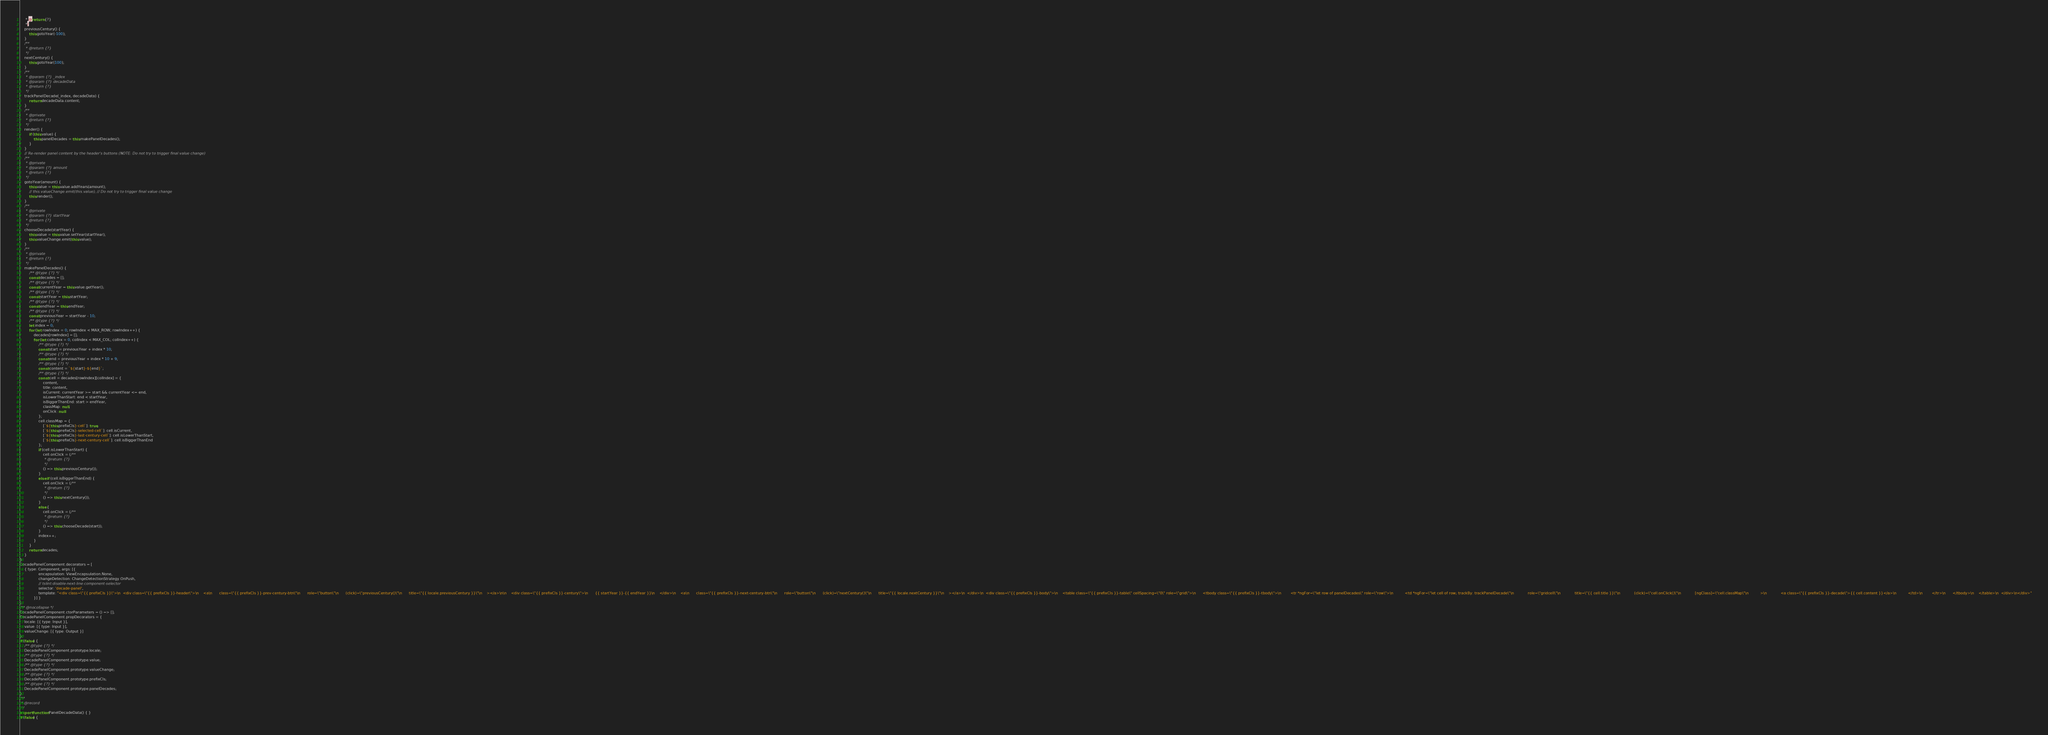<code> <loc_0><loc_0><loc_500><loc_500><_JavaScript_>     * @return {?}
     */
    previousCentury() {
        this.gotoYear(-100);
    }
    /**
     * @return {?}
     */
    nextCentury() {
        this.gotoYear(100);
    }
    /**
     * @param {?} _index
     * @param {?} decadeData
     * @return {?}
     */
    trackPanelDecade(_index, decadeData) {
        return decadeData.content;
    }
    /**
     * @private
     * @return {?}
     */
    render() {
        if (this.value) {
            this.panelDecades = this.makePanelDecades();
        }
    }
    // Re-render panel content by the header's buttons (NOTE: Do not try to trigger final value change)
    /**
     * @private
     * @param {?} amount
     * @return {?}
     */
    gotoYear(amount) {
        this.value = this.value.addYears(amount);
        // this.valueChange.emit(this.value); // Do not try to trigger final value change
        this.render();
    }
    /**
     * @private
     * @param {?} startYear
     * @return {?}
     */
    chooseDecade(startYear) {
        this.value = this.value.setYear(startYear);
        this.valueChange.emit(this.value);
    }
    /**
     * @private
     * @return {?}
     */
    makePanelDecades() {
        /** @type {?} */
        const decades = [];
        /** @type {?} */
        const currentYear = this.value.getYear();
        /** @type {?} */
        const startYear = this.startYear;
        /** @type {?} */
        const endYear = this.endYear;
        /** @type {?} */
        const previousYear = startYear - 10;
        /** @type {?} */
        let index = 0;
        for (let rowIndex = 0; rowIndex < MAX_ROW; rowIndex++) {
            decades[rowIndex] = [];
            for (let colIndex = 0; colIndex < MAX_COL; colIndex++) {
                /** @type {?} */
                const start = previousYear + index * 10;
                /** @type {?} */
                const end = previousYear + index * 10 + 9;
                /** @type {?} */
                const content = `${start}-${end}`;
                /** @type {?} */
                const cell = decades[rowIndex][colIndex] = {
                    content,
                    title: content,
                    isCurrent: currentYear >= start && currentYear <= end,
                    isLowerThanStart: end < startYear,
                    isBiggerThanEnd: start > endYear,
                    classMap: null,
                    onClick: null
                };
                cell.classMap = {
                    [`${this.prefixCls}-cell`]: true,
                    [`${this.prefixCls}-selected-cell`]: cell.isCurrent,
                    [`${this.prefixCls}-last-century-cell`]: cell.isLowerThanStart,
                    [`${this.prefixCls}-next-century-cell`]: cell.isBiggerThanEnd
                };
                if (cell.isLowerThanStart) {
                    cell.onClick = (/**
                     * @return {?}
                     */
                    () => this.previousCentury());
                }
                else if (cell.isBiggerThanEnd) {
                    cell.onClick = (/**
                     * @return {?}
                     */
                    () => this.nextCentury());
                }
                else {
                    cell.onClick = (/**
                     * @return {?}
                     */
                    () => this.chooseDecade(start));
                }
                index++;
            }
        }
        return decades;
    }
}
DecadePanelComponent.decorators = [
    { type: Component, args: [{
                encapsulation: ViewEncapsulation.None,
                changeDetection: ChangeDetectionStrategy.OnPush,
                // tslint:disable-next-line:component-selector
                selector: 'decade-panel',
                template: "<div class=\"{{ prefixCls }}\">\n  <div class=\"{{ prefixCls }}-header\">\n    <a\n      class=\"{{ prefixCls }}-prev-century-btn\"\n      role=\"button\"\n      (click)=\"previousCentury()\"\n      title=\"{{ locale.previousCentury }}\"\n    ></a>\n\n    <div class=\"{{ prefixCls }}-century\">\n      {{ startYear }}-{{ endYear }}\n    </div>\n    <a\n      class=\"{{ prefixCls }}-next-century-btn\"\n      role=\"button\"\n      (click)=\"nextCentury()\"\n      title=\"{{ locale.nextCentury }}\"\n    ></a>\n  </div>\n  <div class=\"{{ prefixCls }}-body\">\n    <table class=\"{{ prefixCls }}-table\" cellSpacing=\"0\" role=\"grid\">\n      <tbody class=\"{{ prefixCls }}-tbody\">\n        <tr *ngFor=\"let row of panelDecades\" role=\"row\">\n          <td *ngFor=\"let cell of row; trackBy: trackPanelDecade\"\n            role=\"gridcell\"\n            title=\"{{ cell.title }}\"\n            (click)=\"cell.onClick()\"\n            [ngClass]=\"cell.classMap\"\n          >\n            <a class=\"{{ prefixCls }}-decade\">{{ cell.content }}</a>\n          </td>\n        </tr>\n      </tbody>\n    </table>\n  </div>\n</div>"
            }] }
];
/** @nocollapse */
DecadePanelComponent.ctorParameters = () => [];
DecadePanelComponent.propDecorators = {
    locale: [{ type: Input }],
    value: [{ type: Input }],
    valueChange: [{ type: Output }]
};
if (false) {
    /** @type {?} */
    DecadePanelComponent.prototype.locale;
    /** @type {?} */
    DecadePanelComponent.prototype.value;
    /** @type {?} */
    DecadePanelComponent.prototype.valueChange;
    /** @type {?} */
    DecadePanelComponent.prototype.prefixCls;
    /** @type {?} */
    DecadePanelComponent.prototype.panelDecades;
}
/**
 * @record
 */
export function PanelDecadeData() { }
if (false) {</code> 